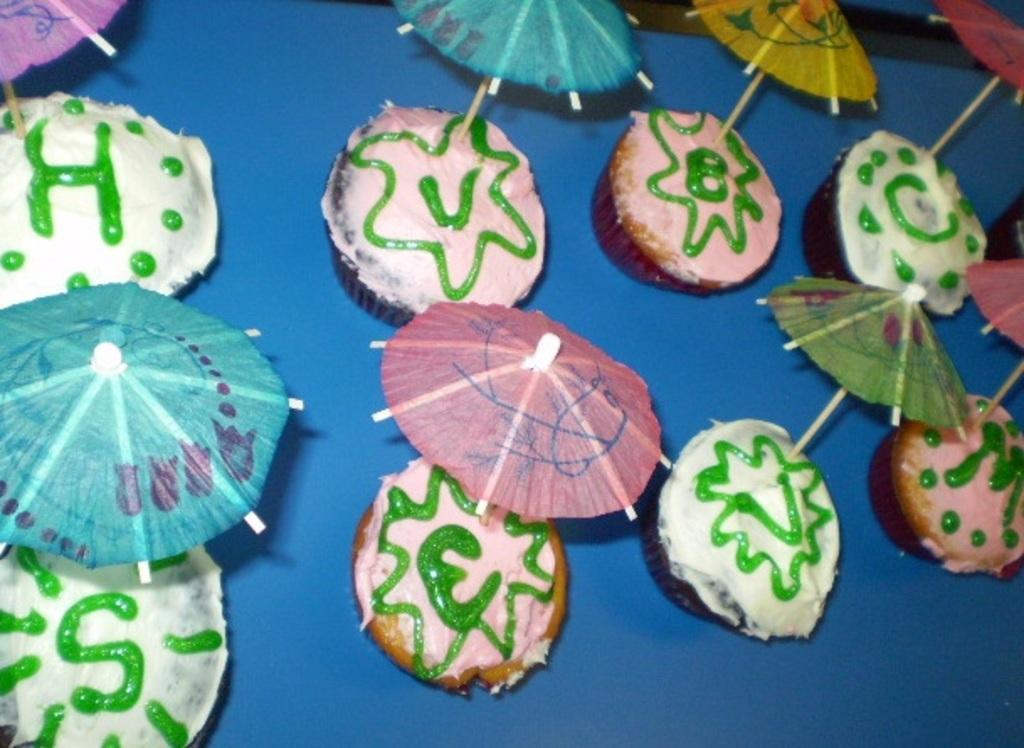Describe this image in one or two sentences. In this image, we can see cakes placed on the table. 